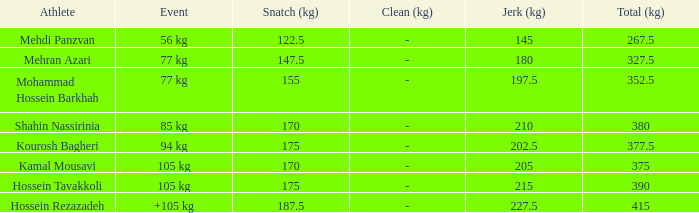What event has a 122.5 snatch rate? 56 kg. 